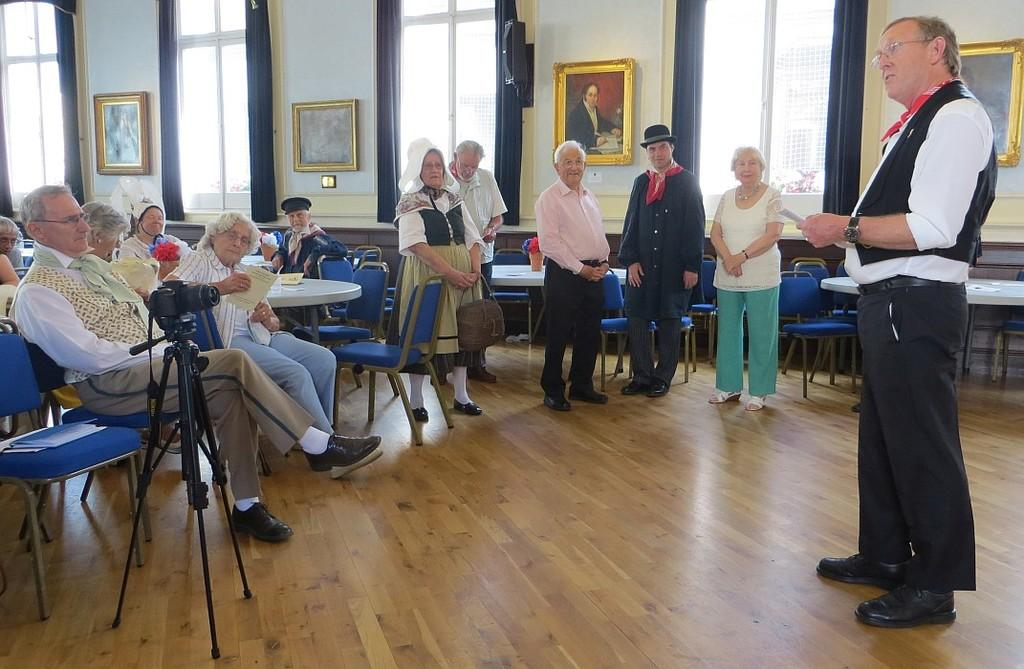How many people are present in the image? There are several people in the image. What are the people doing in the image? The people are sitting at a table. What object related to photography can be seen in the image? There is a camera and stand in the image. What is the guy holding in his hand? The guy is holding a letter in his hand. What is the guy doing while holding the letter? The guy is talking to the people at the table. What type of toy is on the table in the image? There is no toy present on the table in the image. What team are the people supporting in the image? There is no indication of a team or any sports-related activity in the image. 